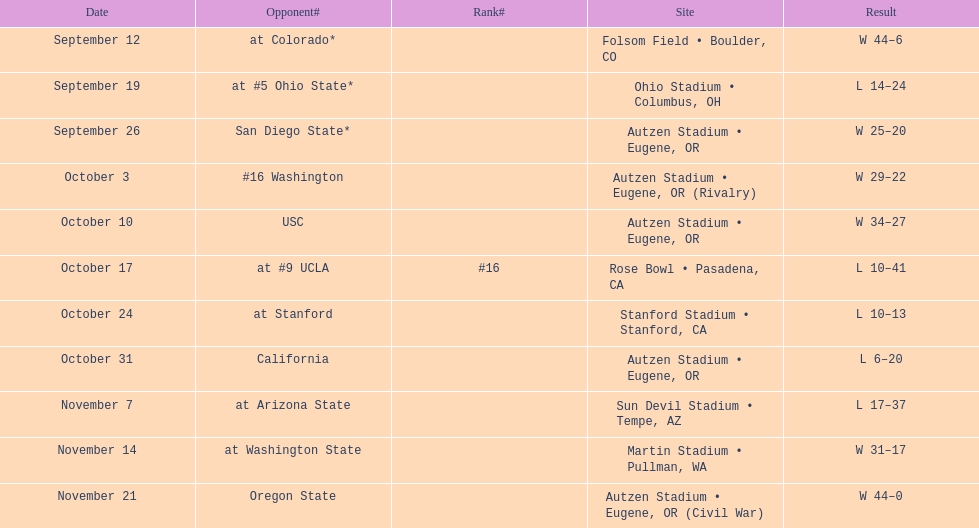How many successful matches are noted for the season? 6. 